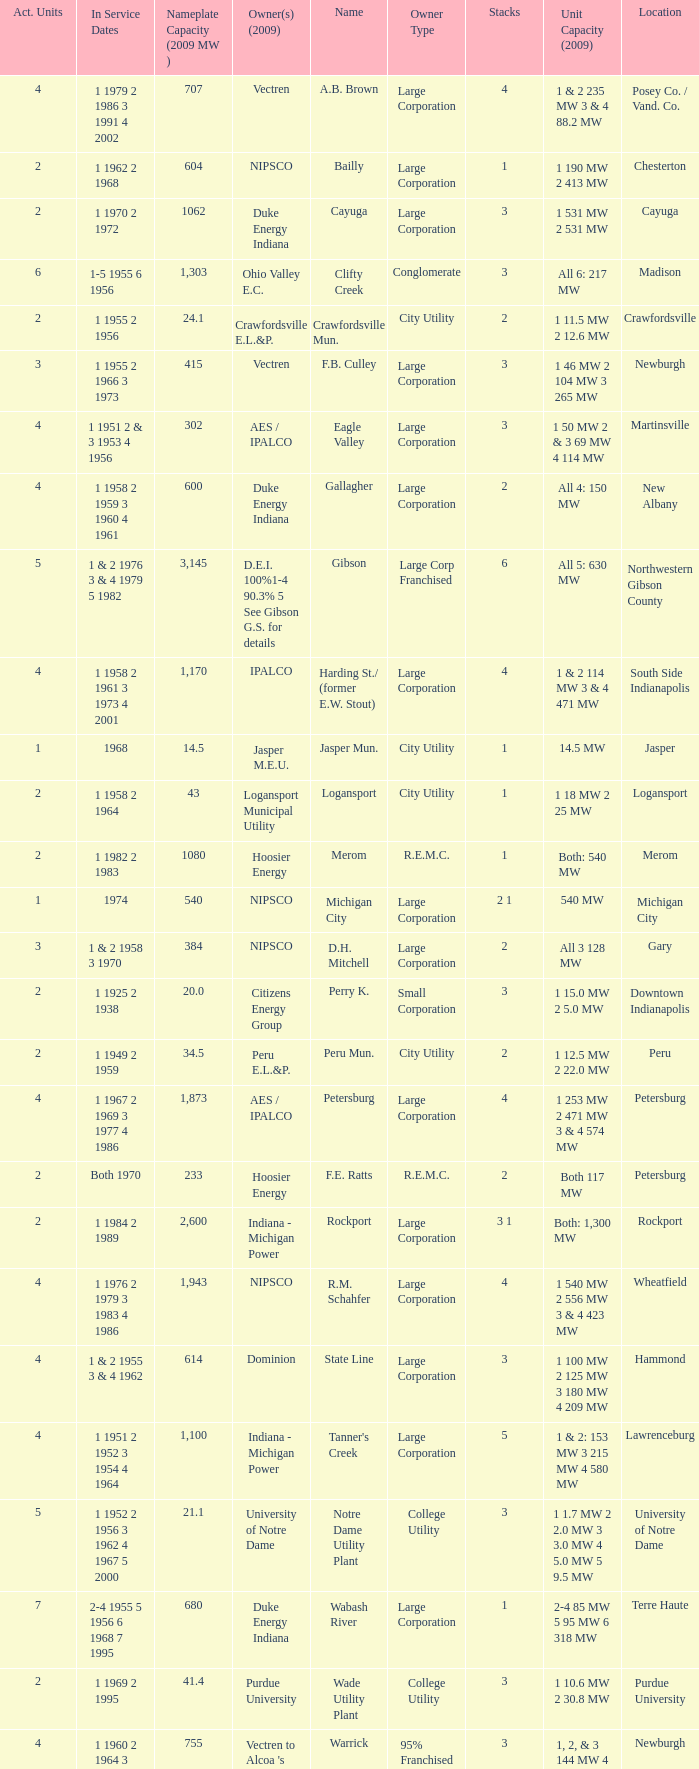Name the number for service dates for hoosier energy for petersburg 1.0. 